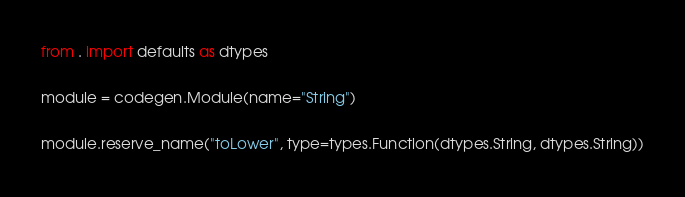<code> <loc_0><loc_0><loc_500><loc_500><_Python_>from . import defaults as dtypes

module = codegen.Module(name="String")

module.reserve_name("toLower", type=types.Function(dtypes.String, dtypes.String))
</code> 